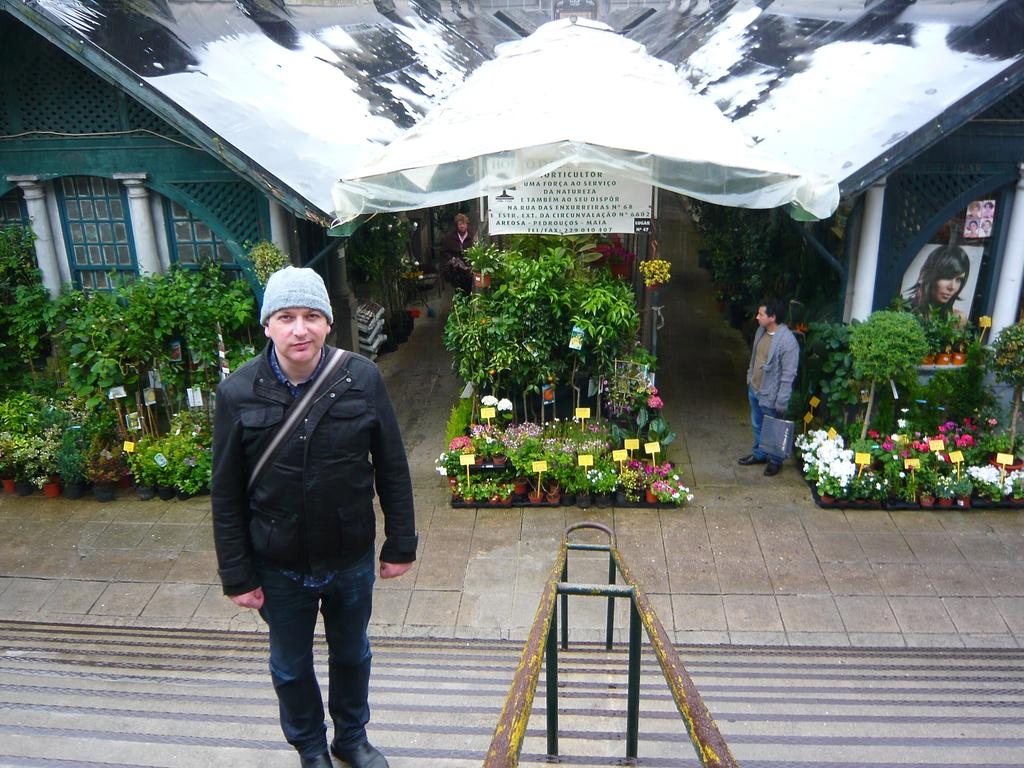How many people are in the image? There are two men in the image. What can be seen in the image besides the men? There are plants, flowers, posters, a board, and houses in the background of the image. What type of decorations are present in the image? The posters and flowers can be considered decorations in the image. What is the background of the image? The background of the image includes houses. What language are the men speaking in the image? There is no information about the language being spoken in the image. How many family members are present in the image? There is no information about family members in the image. 